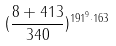<formula> <loc_0><loc_0><loc_500><loc_500>( \frac { 8 + 4 1 3 } { 3 4 0 } ) ^ { 1 9 1 ^ { 9 } \cdot 1 6 3 }</formula> 